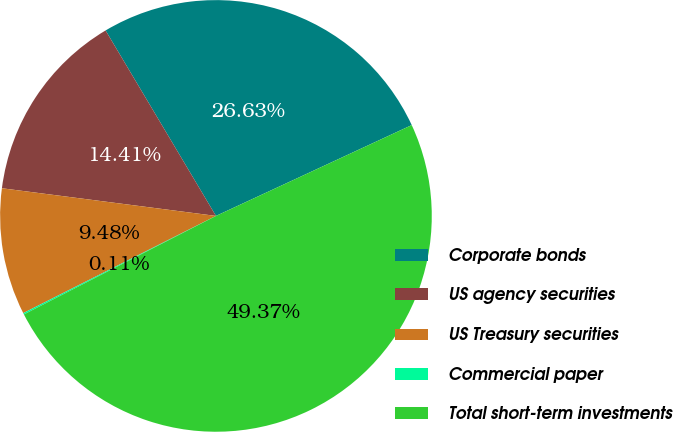Convert chart. <chart><loc_0><loc_0><loc_500><loc_500><pie_chart><fcel>Corporate bonds<fcel>US agency securities<fcel>US Treasury securities<fcel>Commercial paper<fcel>Total short-term investments<nl><fcel>26.63%<fcel>14.41%<fcel>9.48%<fcel>0.11%<fcel>49.37%<nl></chart> 